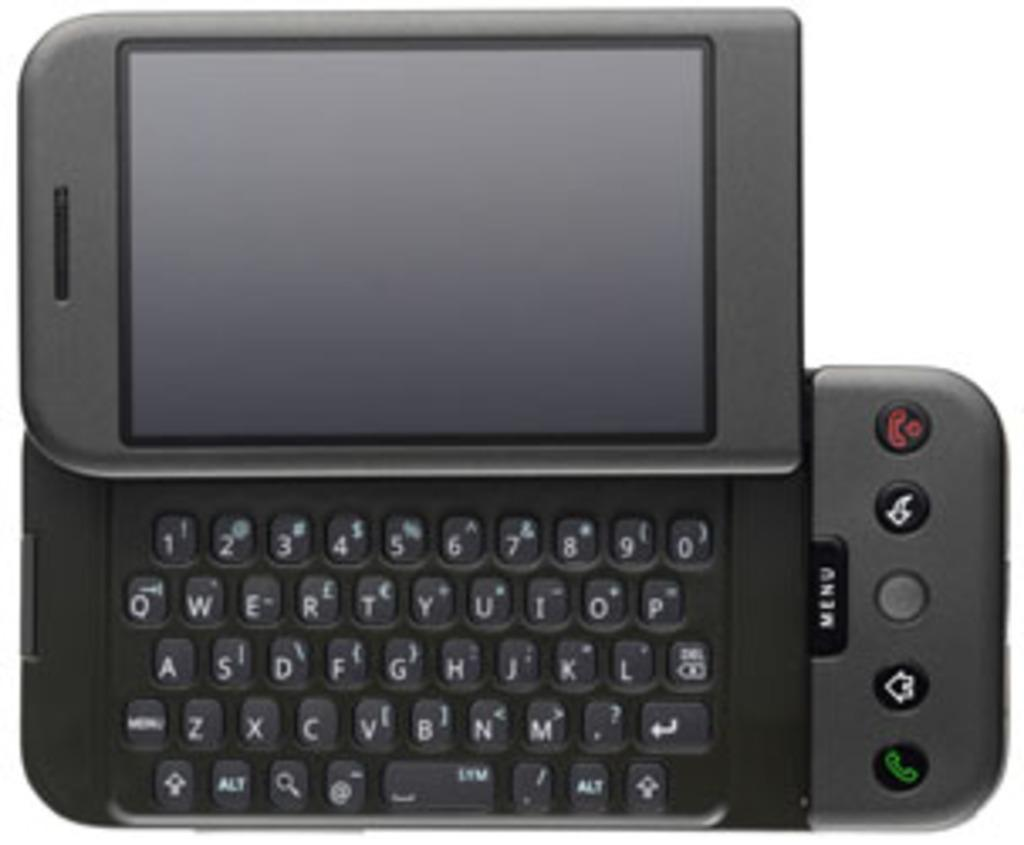What electronic device is present in the image? There is a mobile phone in the image. What is the color of the mobile phone? The mobile phone is black in color. What observation can be made about the person's knee in the image? There is no person or knee visible in the image; it only features a black mobile phone. 